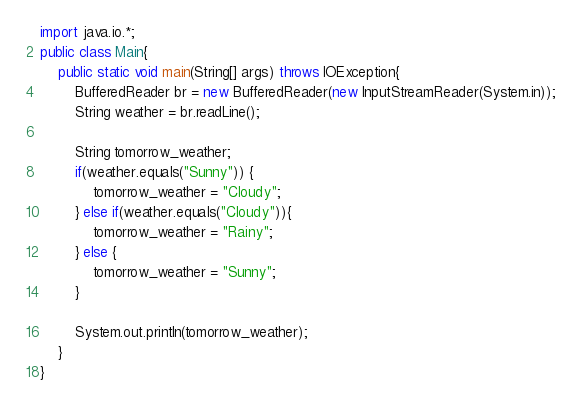<code> <loc_0><loc_0><loc_500><loc_500><_Java_>import java.io.*;
public class Main{
	public static void main(String[] args) throws IOException{
		BufferedReader br = new BufferedReader(new InputStreamReader(System.in));
		String weather = br.readLine();
		
		String tomorrow_weather;
		if(weather.equals("Sunny")) {
			tomorrow_weather = "Cloudy";
		} else if(weather.equals("Cloudy")){
			tomorrow_weather = "Rainy";
		} else {
			tomorrow_weather = "Sunny";
		}

		System.out.println(tomorrow_weather);
	}
}</code> 